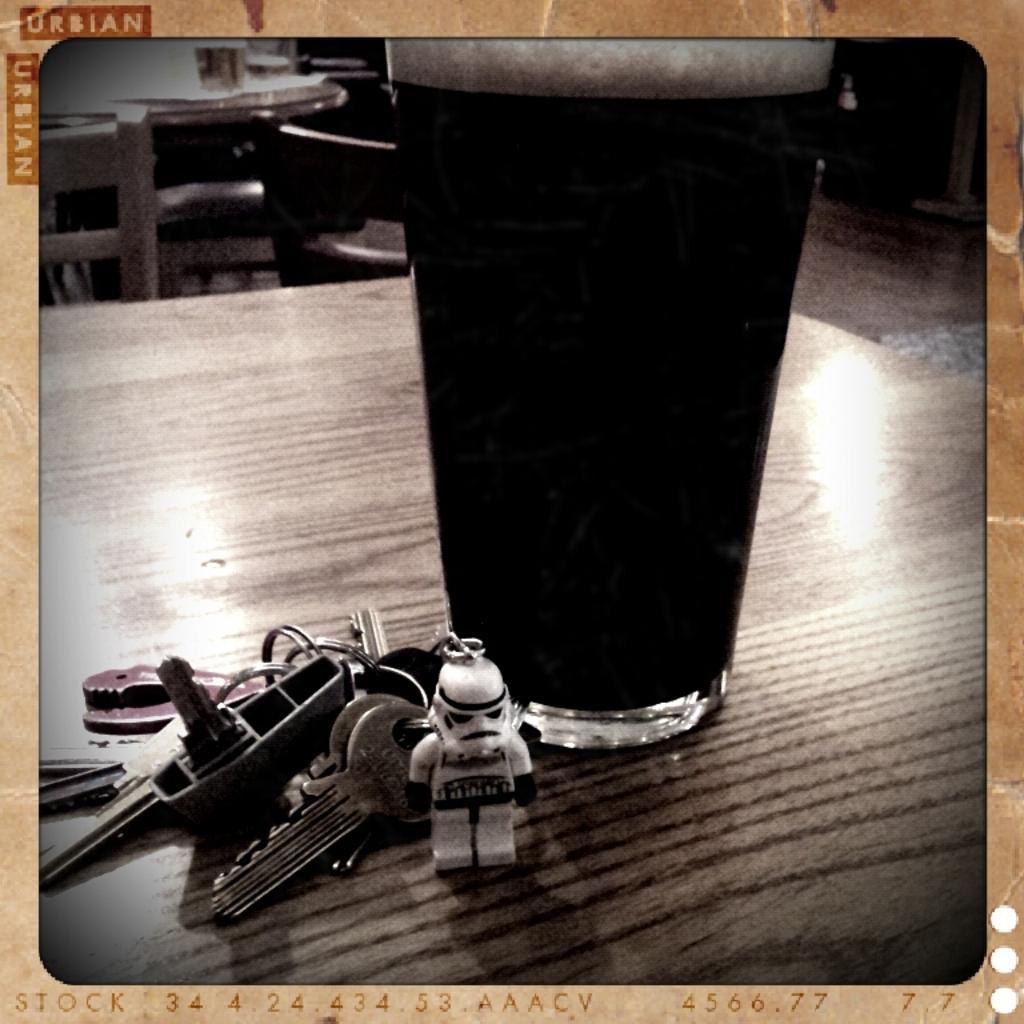Can you describe this image briefly? In this picture there is a glass on the table, besides it there is a bunch of keys. 